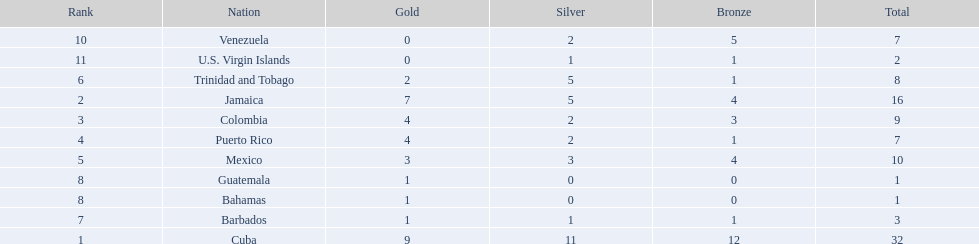Which teams have at exactly 4 gold medals? Colombia, Puerto Rico. Of those teams which has exactly 1 bronze medal? Puerto Rico. 